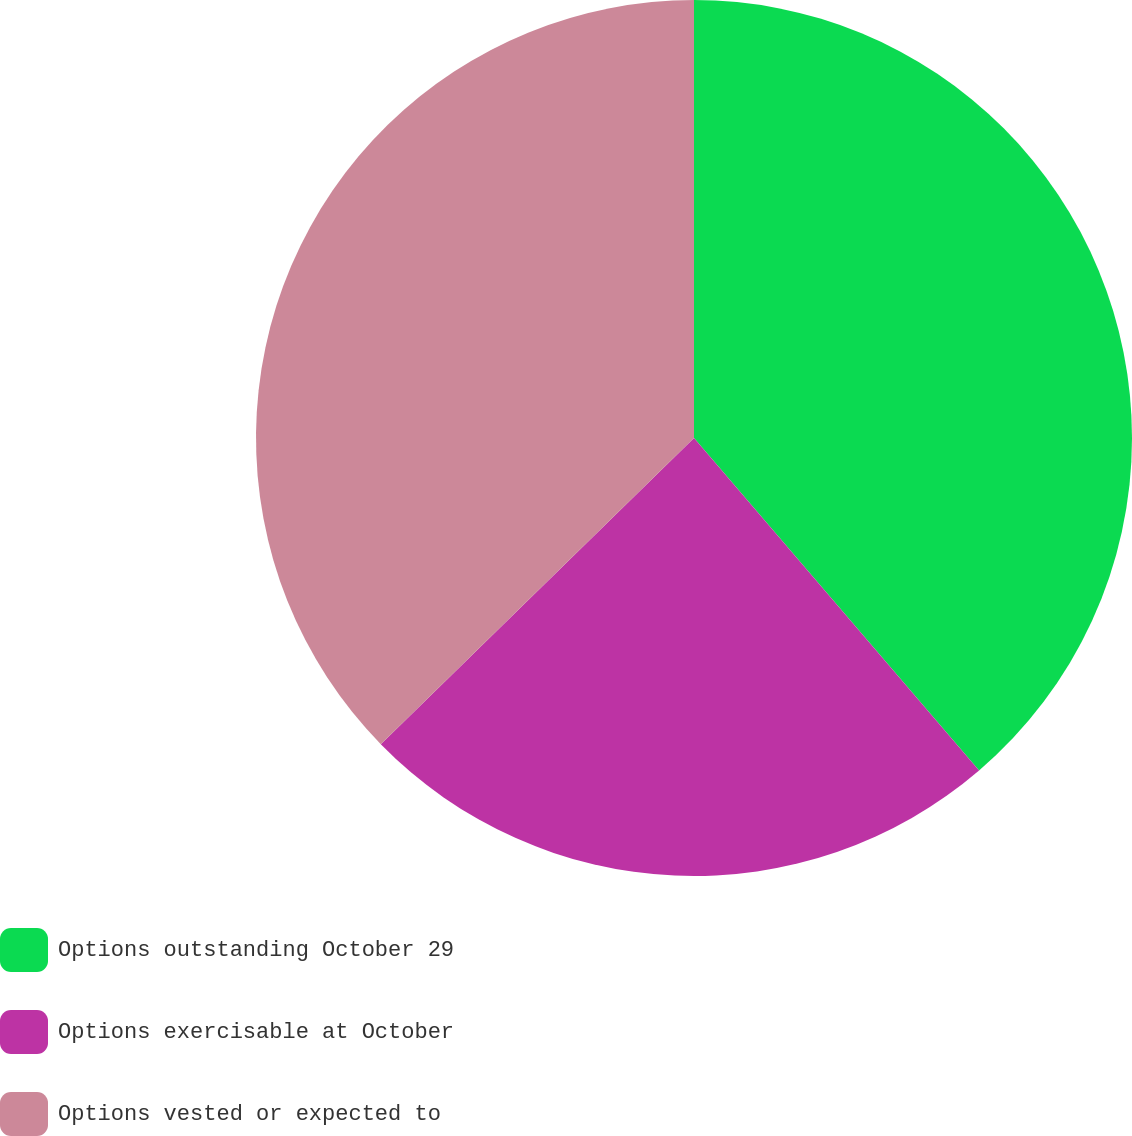Convert chart. <chart><loc_0><loc_0><loc_500><loc_500><pie_chart><fcel>Options outstanding October 29<fcel>Options exercisable at October<fcel>Options vested or expected to<nl><fcel>38.72%<fcel>23.96%<fcel>37.32%<nl></chart> 